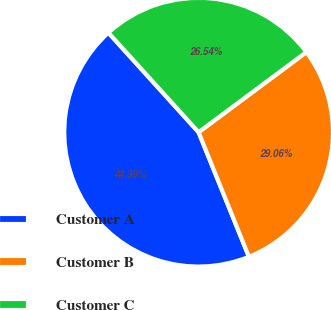Convert chart. <chart><loc_0><loc_0><loc_500><loc_500><pie_chart><fcel>Customer A<fcel>Customer B<fcel>Customer C<nl><fcel>44.39%<fcel>29.06%<fcel>26.54%<nl></chart> 